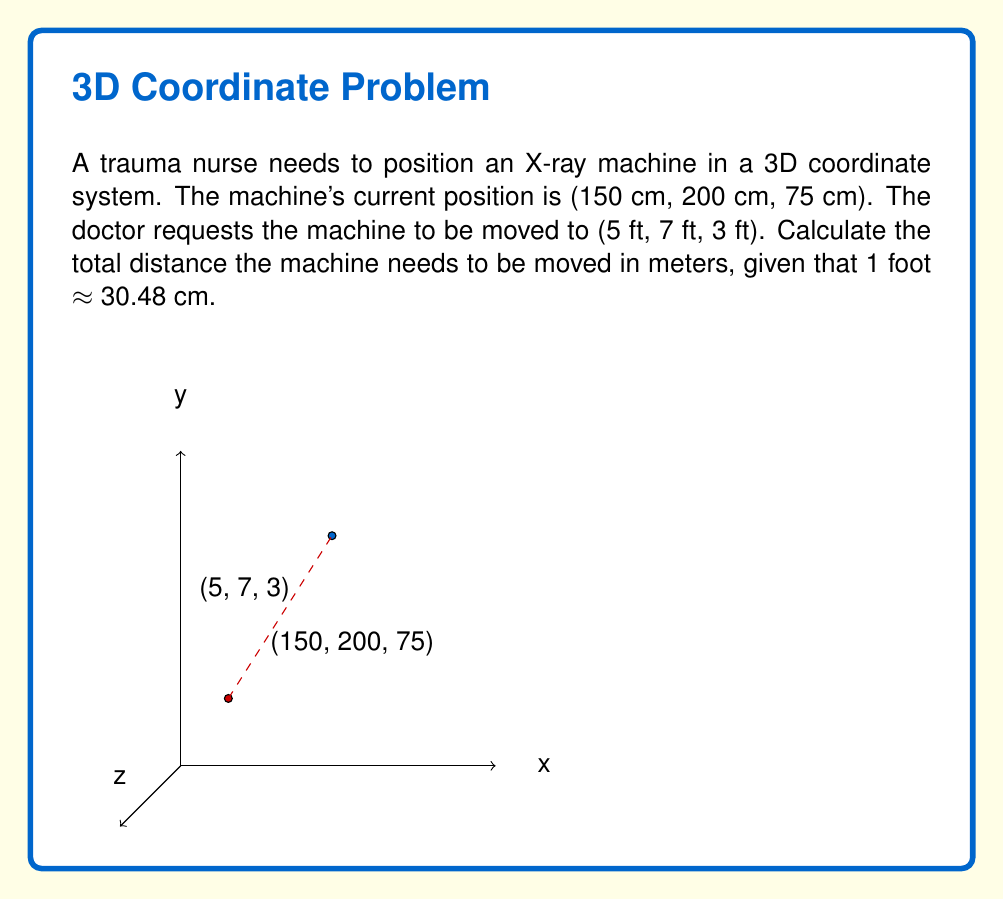Solve this math problem. To solve this problem, we need to follow these steps:

1) First, convert the final position from feet to centimeters:
   $5 \text{ ft} = 5 \times 30.48 \text{ cm} = 152.4 \text{ cm}$
   $7 \text{ ft} = 7 \times 30.48 \text{ cm} = 213.36 \text{ cm}$
   $3 \text{ ft} = 3 \times 30.48 \text{ cm} = 91.44 \text{ cm}$

2) Now we have both positions in centimeters:
   Initial position: $(150 \text{ cm}, 200 \text{ cm}, 75 \text{ cm})$
   Final position: $(152.4 \text{ cm}, 213.36 \text{ cm}, 91.44 \text{ cm})$

3) Calculate the difference in each dimension:
   $\Delta x = 152.4 - 150 = 2.4 \text{ cm}$
   $\Delta y = 213.36 - 200 = 13.36 \text{ cm}$
   $\Delta z = 91.44 - 75 = 16.44 \text{ cm}$

4) Use the 3D distance formula to calculate the total distance:
   $$d = \sqrt{(\Delta x)^2 + (\Delta y)^2 + (\Delta z)^2}$$
   $$d = \sqrt{(2.4)^2 + (13.36)^2 + (16.44)^2}$$
   $$d = \sqrt{5.76 + 178.4896 + 270.2736}$$
   $$d = \sqrt{454.5232} \approx 21.32 \text{ cm}$$

5) Convert the result to meters:
   $21.32 \text{ cm} = 0.2132 \text{ m}$

Therefore, the total distance the X-ray machine needs to be moved is approximately 0.2132 meters.
Answer: $0.2132 \text{ m}$ 